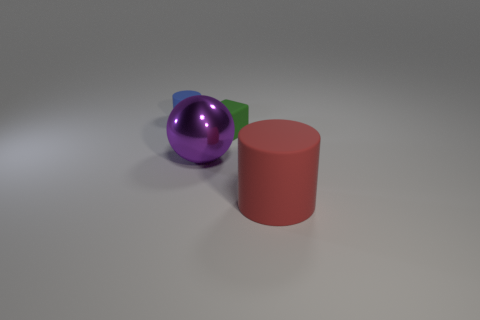Add 4 small blue objects. How many objects exist? 8 Subtract all cubes. How many objects are left? 3 Subtract all small spheres. Subtract all small things. How many objects are left? 2 Add 2 small green matte things. How many small green matte things are left? 3 Add 4 big blue cylinders. How many big blue cylinders exist? 4 Subtract 0 purple blocks. How many objects are left? 4 Subtract all red cubes. Subtract all brown cylinders. How many cubes are left? 1 